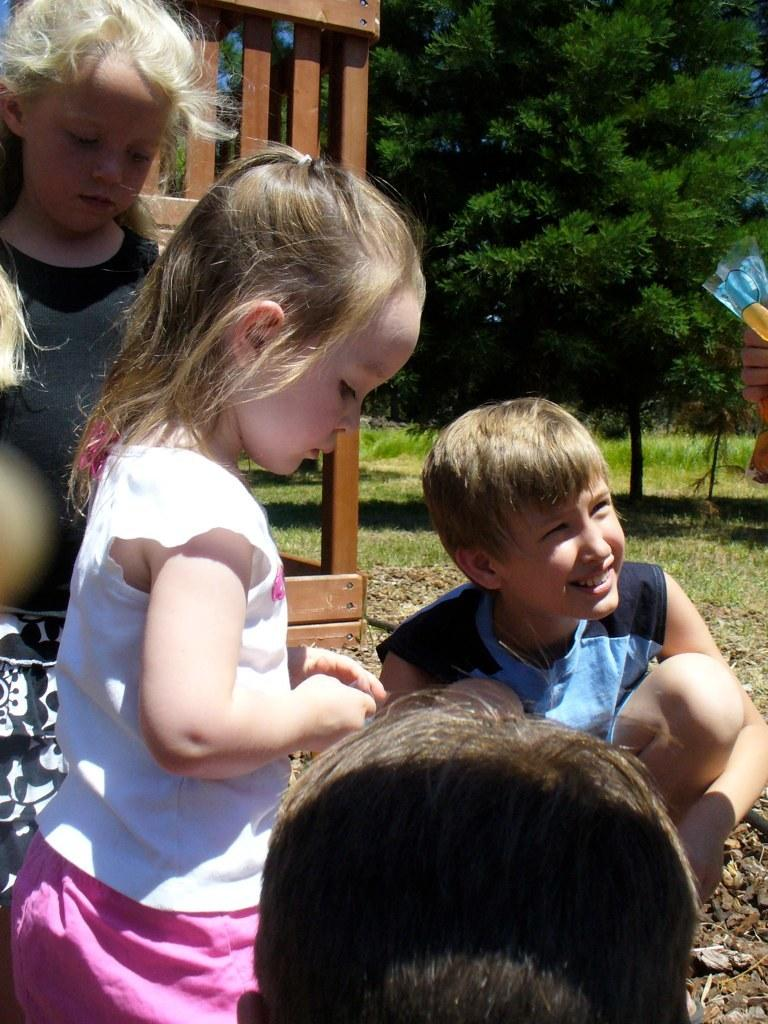What is the primary setting of the image? The primary setting of the image is on land. What type of vegetation is present on the ground in the image? There is grass on the ground in the image. What can be seen in the background of the image? There are trees in the background of the image. How is one of the kids positioned in the image? One of the kids is sitting on the ground and smiling. What type of pleasure does the father in the image derive from the country? There is no father or country mentioned in the image; it features kids on land with grass and trees in the background. 